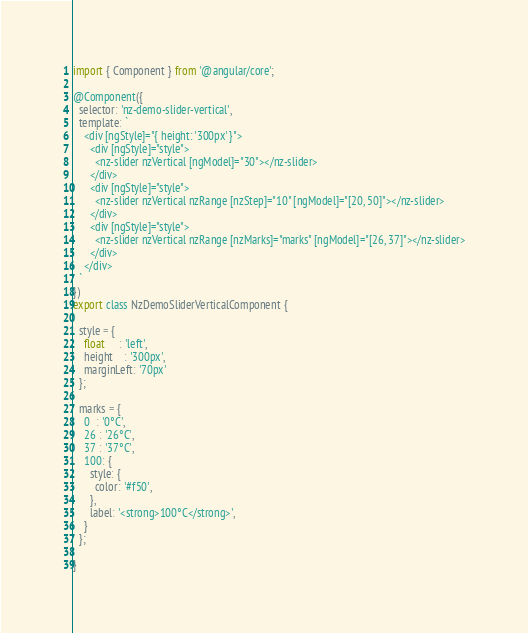<code> <loc_0><loc_0><loc_500><loc_500><_TypeScript_>import { Component } from '@angular/core';

@Component({
  selector: 'nz-demo-slider-vertical',
  template: `
    <div [ngStyle]="{ height: '300px' }">
      <div [ngStyle]="style">
        <nz-slider nzVertical [ngModel]="30"></nz-slider>
      </div>
      <div [ngStyle]="style">
        <nz-slider nzVertical nzRange [nzStep]="10" [ngModel]="[20, 50]"></nz-slider>
      </div>
      <div [ngStyle]="style">
        <nz-slider nzVertical nzRange [nzMarks]="marks" [ngModel]="[26, 37]"></nz-slider>
      </div>
    </div>
  `
})
export class NzDemoSliderVerticalComponent {

  style = {
    float     : 'left',
    height    : '300px',
    marginLeft: '70px'
  };

  marks = {
    0  : '0°C',
    26 : '26°C',
    37 : '37°C',
    100: {
      style: {
        color: '#f50',
      },
      label: '<strong>100°C</strong>',
    }
  };

}
</code> 